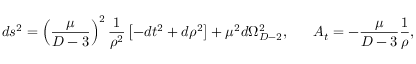<formula> <loc_0><loc_0><loc_500><loc_500>d s ^ { 2 } = \left ( { \frac { \mu } { D - 3 } } \right ) ^ { 2 } { \frac { 1 } { \rho ^ { 2 } } } \left [ - d t ^ { 2 } + d \rho ^ { 2 } \right ] + \mu ^ { 2 } d \Omega _ { D - 2 } ^ { 2 } , \quad \ A _ { t } = - { \frac { \mu } { D - 3 } } { \frac { 1 } { \rho } } ,</formula> 